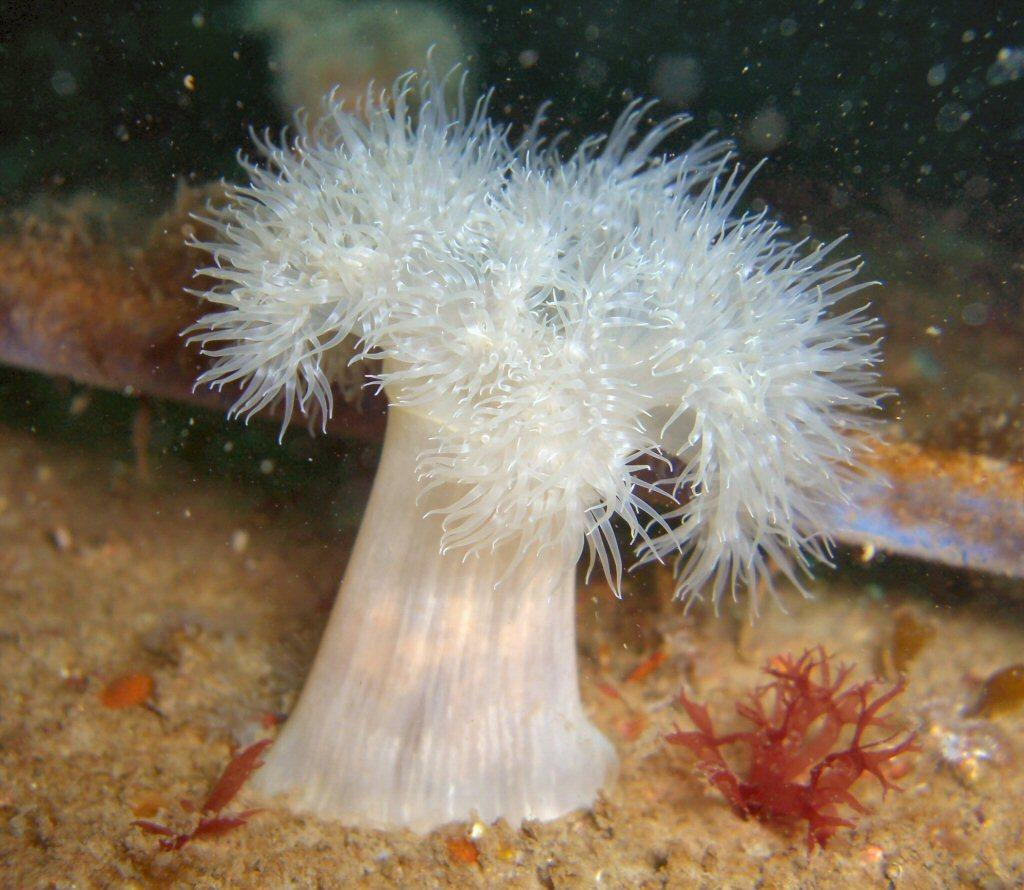Where was the image taken? The image was taken underwater. What types of creatures can be seen in the image? There are marine species visible in the image. What type of celery can be seen growing in the image? There is no celery present in the image, as it was taken underwater and features marine species. 